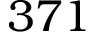<formula> <loc_0><loc_0><loc_500><loc_500>3 7 1</formula> 